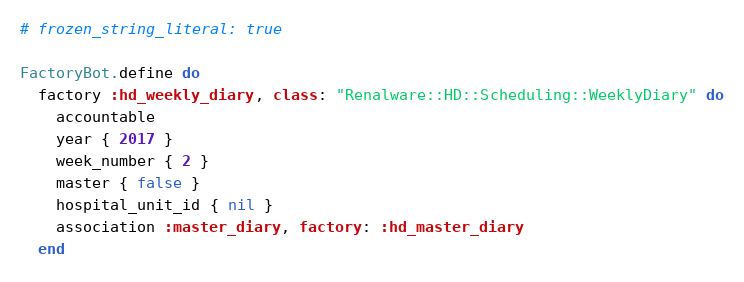Convert code to text. <code><loc_0><loc_0><loc_500><loc_500><_Ruby_># frozen_string_literal: true

FactoryBot.define do
  factory :hd_weekly_diary, class: "Renalware::HD::Scheduling::WeeklyDiary" do
    accountable
    year { 2017 }
    week_number { 2 }
    master { false }
    hospital_unit_id { nil }
    association :master_diary, factory: :hd_master_diary
  end
</code> 